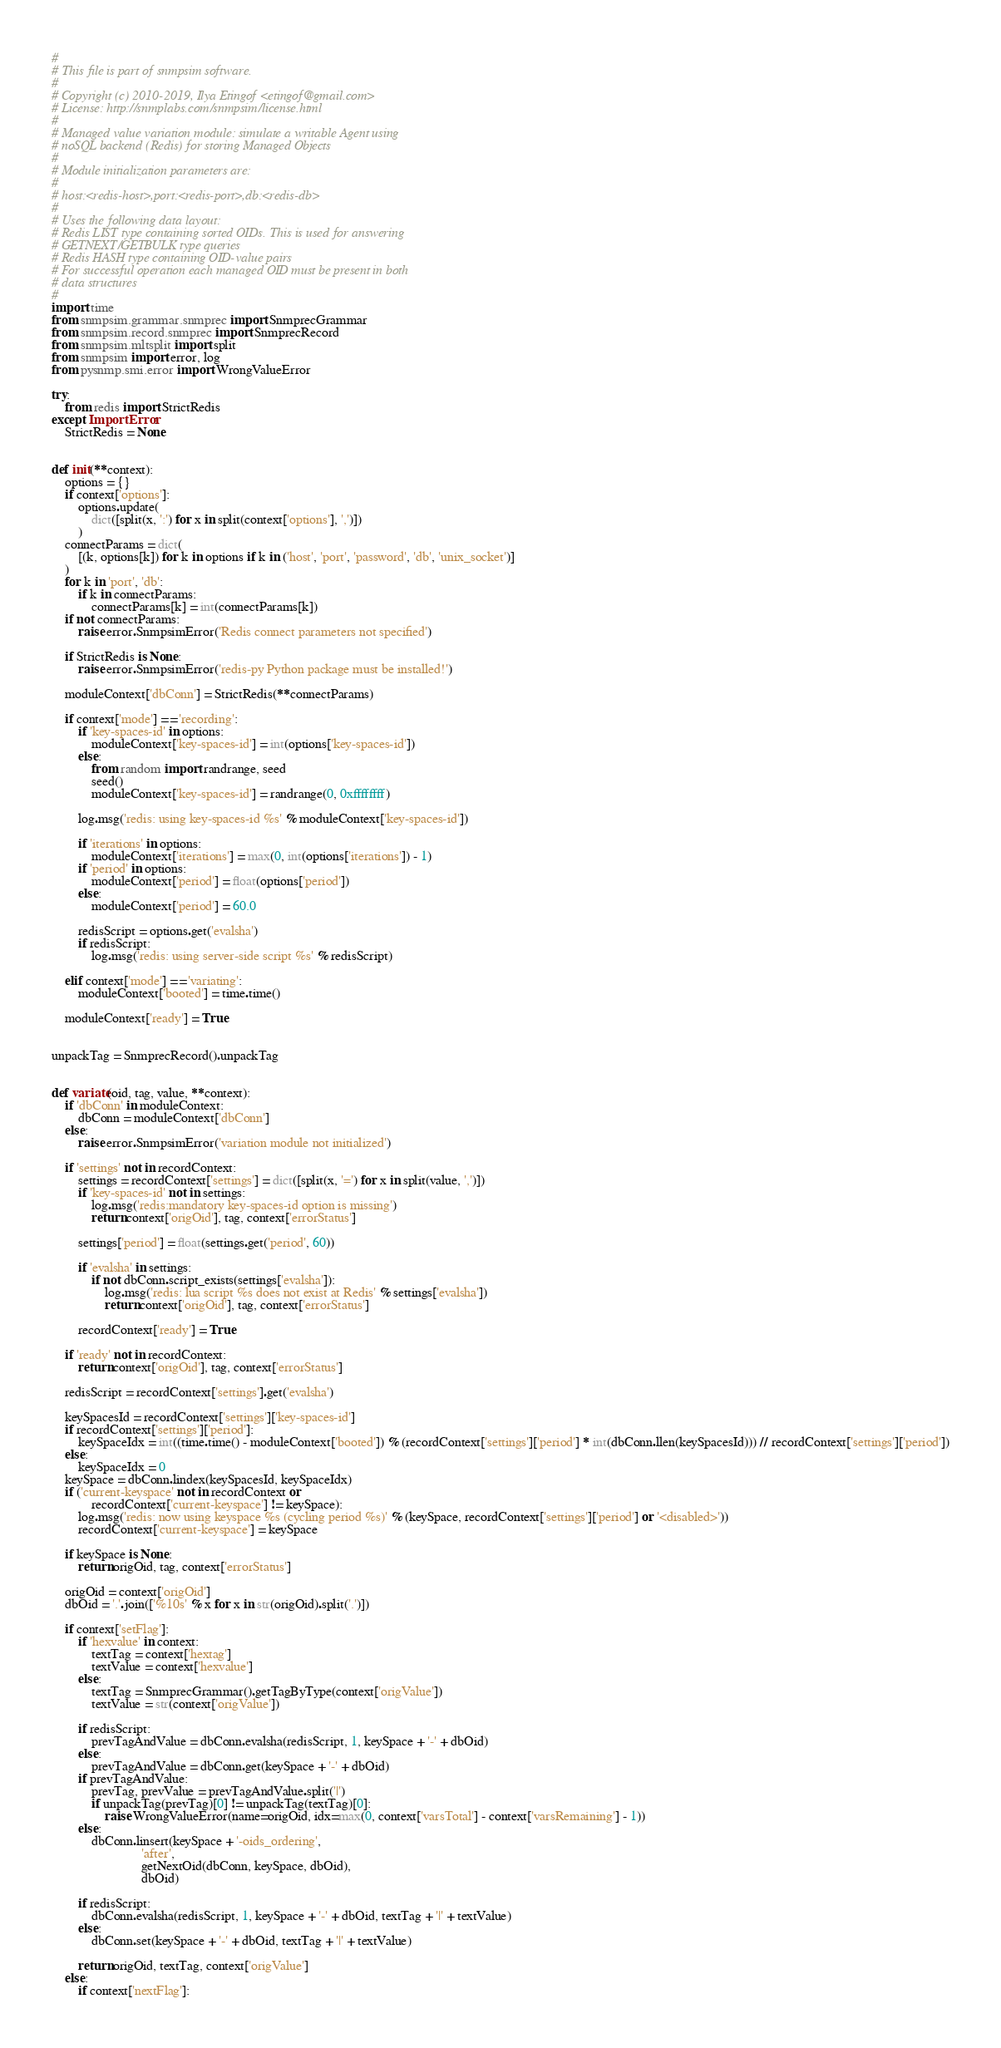Convert code to text. <code><loc_0><loc_0><loc_500><loc_500><_Python_>#
# This file is part of snmpsim software.
#
# Copyright (c) 2010-2019, Ilya Etingof <etingof@gmail.com>
# License: http://snmplabs.com/snmpsim/license.html
#
# Managed value variation module: simulate a writable Agent using
# noSQL backend (Redis) for storing Managed Objects
#
# Module initialization parameters are:
#
# host:<redis-host>,port:<redis-port>,db:<redis-db> 
#
# Uses the following data layout:
# Redis LIST type containing sorted OIDs. This is used for answering 
# GETNEXT/GETBULK type queries
# Redis HASH type containing OID-value pairs
# For successful operation each managed OID must be present in both
# data structures
#
import time
from snmpsim.grammar.snmprec import SnmprecGrammar
from snmpsim.record.snmprec import SnmprecRecord
from snmpsim.mltsplit import split
from snmpsim import error, log
from pysnmp.smi.error import WrongValueError

try:
    from redis import StrictRedis
except ImportError:
    StrictRedis = None


def init(**context):
    options = {}
    if context['options']:
        options.update(
            dict([split(x, ':') for x in split(context['options'], ',')])
        )
    connectParams = dict(
        [(k, options[k]) for k in options if k in ('host', 'port', 'password', 'db', 'unix_socket')]
    )
    for k in 'port', 'db':
        if k in connectParams:
            connectParams[k] = int(connectParams[k])
    if not connectParams:
        raise error.SnmpsimError('Redis connect parameters not specified')

    if StrictRedis is None:
        raise error.SnmpsimError('redis-py Python package must be installed!')

    moduleContext['dbConn'] = StrictRedis(**connectParams)

    if context['mode'] == 'recording':
        if 'key-spaces-id' in options:
            moduleContext['key-spaces-id'] = int(options['key-spaces-id'])
        else:
            from random import randrange, seed
            seed()
            moduleContext['key-spaces-id'] = randrange(0, 0xffffffff)

        log.msg('redis: using key-spaces-id %s' % moduleContext['key-spaces-id'])

        if 'iterations' in options:
            moduleContext['iterations'] = max(0, int(options['iterations']) - 1)
        if 'period' in options:
            moduleContext['period'] = float(options['period'])
        else:
            moduleContext['period'] = 60.0

        redisScript = options.get('evalsha')
        if redisScript:
            log.msg('redis: using server-side script %s' % redisScript)

    elif context['mode'] == 'variating':
        moduleContext['booted'] = time.time()

    moduleContext['ready'] = True


unpackTag = SnmprecRecord().unpackTag


def variate(oid, tag, value, **context):
    if 'dbConn' in moduleContext:
        dbConn = moduleContext['dbConn']
    else:
        raise error.SnmpsimError('variation module not initialized')

    if 'settings' not in recordContext:
        settings = recordContext['settings'] = dict([split(x, '=') for x in split(value, ',')])
        if 'key-spaces-id' not in settings:
            log.msg('redis:mandatory key-spaces-id option is missing')
            return context['origOid'], tag, context['errorStatus']

        settings['period'] = float(settings.get('period', 60))

        if 'evalsha' in settings:
            if not dbConn.script_exists(settings['evalsha']):
                log.msg('redis: lua script %s does not exist at Redis' % settings['evalsha'])
                return context['origOid'], tag, context['errorStatus']

        recordContext['ready'] = True

    if 'ready' not in recordContext:
        return context['origOid'], tag, context['errorStatus']

    redisScript = recordContext['settings'].get('evalsha')

    keySpacesId = recordContext['settings']['key-spaces-id']
    if recordContext['settings']['period']:
        keySpaceIdx = int((time.time() - moduleContext['booted']) % (recordContext['settings']['period'] * int(dbConn.llen(keySpacesId))) // recordContext['settings']['period'])
    else:
        keySpaceIdx = 0
    keySpace = dbConn.lindex(keySpacesId, keySpaceIdx)
    if ('current-keyspace' not in recordContext or
            recordContext['current-keyspace'] != keySpace):
        log.msg('redis: now using keyspace %s (cycling period %s)' % (keySpace, recordContext['settings']['period'] or '<disabled>'))
        recordContext['current-keyspace'] = keySpace

    if keySpace is None:
        return origOid, tag, context['errorStatus']

    origOid = context['origOid']
    dbOid = '.'.join(['%10s' % x for x in str(origOid).split('.')])

    if context['setFlag']:
        if 'hexvalue' in context:
            textTag = context['hextag']
            textValue = context['hexvalue']
        else:
            textTag = SnmprecGrammar().getTagByType(context['origValue'])
            textValue = str(context['origValue'])

        if redisScript:
            prevTagAndValue = dbConn.evalsha(redisScript, 1, keySpace + '-' + dbOid)
        else:
            prevTagAndValue = dbConn.get(keySpace + '-' + dbOid)
        if prevTagAndValue:
            prevTag, prevValue = prevTagAndValue.split('|')
            if unpackTag(prevTag)[0] != unpackTag(textTag)[0]:
                raise WrongValueError(name=origOid, idx=max(0, context['varsTotal'] - context['varsRemaining'] - 1))
        else:
            dbConn.linsert(keySpace + '-oids_ordering',
                           'after',
                           getNextOid(dbConn, keySpace, dbOid),
                           dbOid)

        if redisScript:
            dbConn.evalsha(redisScript, 1, keySpace + '-' + dbOid, textTag + '|' + textValue)
        else:
            dbConn.set(keySpace + '-' + dbOid, textTag + '|' + textValue)

        return origOid, textTag, context['origValue']
    else:
        if context['nextFlag']:</code> 